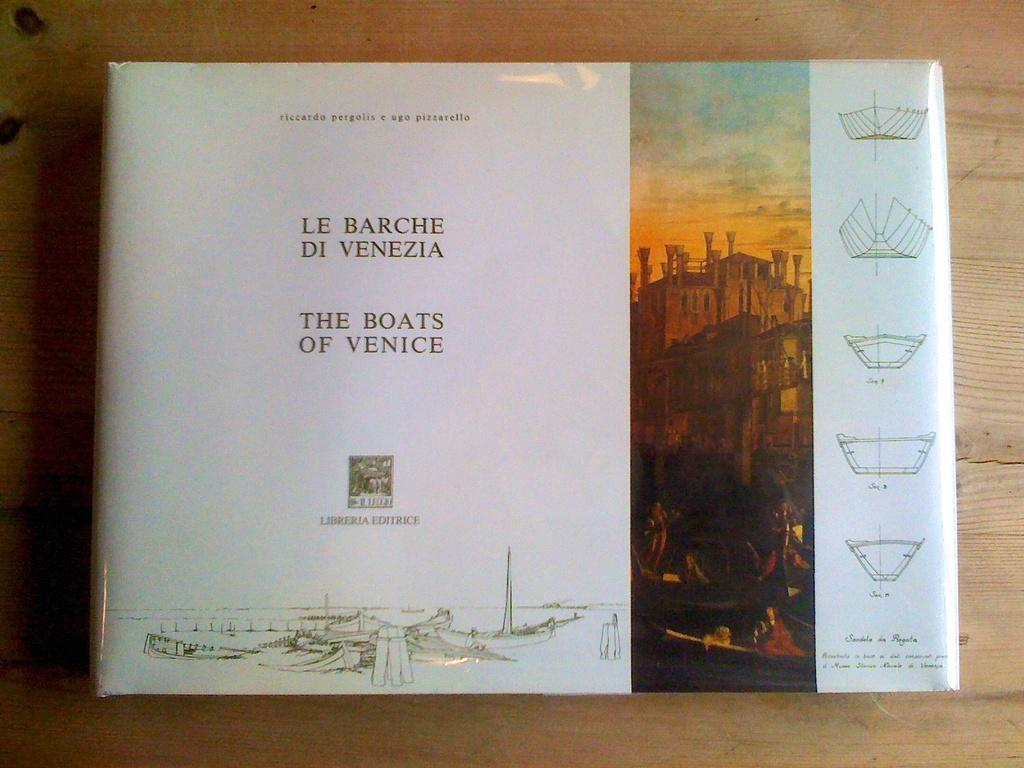<image>
Describe the image concisely. The cover of a book titled The Boats of Venice showing diagrams of boat hulls. 